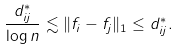Convert formula to latex. <formula><loc_0><loc_0><loc_500><loc_500>\frac { d _ { i j } ^ { * } } { \log n } \lesssim \| f _ { i } - f _ { j } \| _ { 1 } \leq d _ { i j } ^ { * } .</formula> 